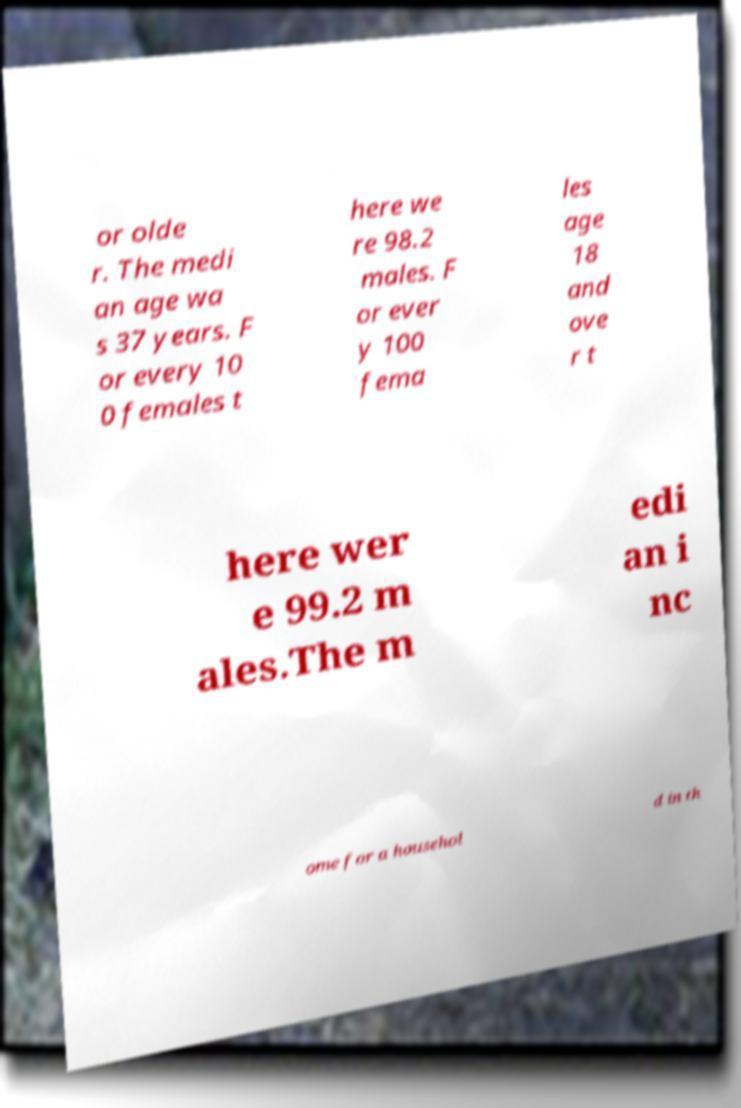Can you accurately transcribe the text from the provided image for me? or olde r. The medi an age wa s 37 years. F or every 10 0 females t here we re 98.2 males. F or ever y 100 fema les age 18 and ove r t here wer e 99.2 m ales.The m edi an i nc ome for a househol d in th 